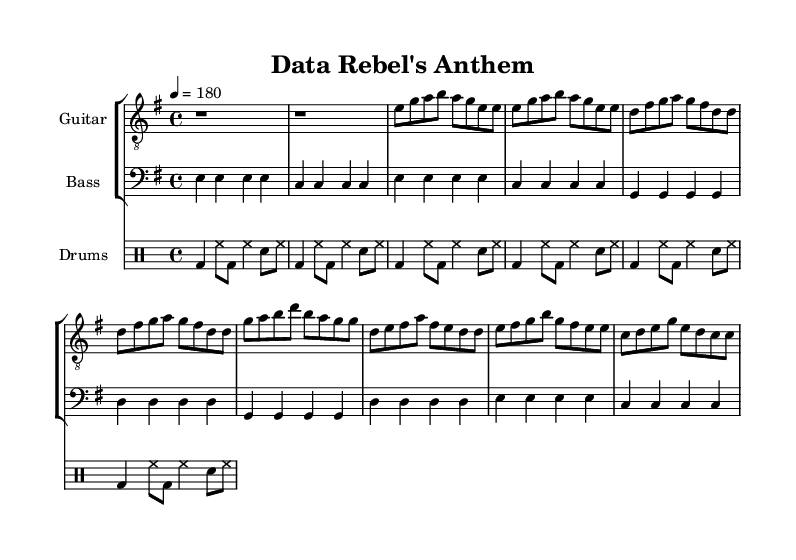What is the key signature of this music? The key signature is indicated at the beginning of the score. It shows one sharp, which corresponds to the E minor key signature.
Answer: E minor What is the time signature of this music? The time signature, located right after the key signature, is represented by 4/4. This indicates that there are four beats per measure and that the quarter note gets one beat.
Answer: 4/4 What is the tempo marking for this piece? The tempo marking, located at the beginning of the score, indicates that the piece is to be played at a speed of 180 beats per minute.
Answer: 180 How many measures are in the verse section of the song? The verse section consists of two repeated musical phrases, each containing four measures, totaling eight measures in the verse.
Answer: Eight measures In the chorus, what is the highest note played in the guitar part? By examining the chorus section of the guitar music, the highest note is B, which occurs in both of the two lines of the chorus.
Answer: B What musical style does this piece primarily reflect? The elements of fast tempo, straightforward chords, and rebellious lyrics are indicative of the punk rock genre, making it reflect punk music style.
Answer: Punk rock How many times is the word "data" mentioned in the lyrics? In the lyric section, the word "data" appears four times throughout the entire song, signifying its importance to the anthem's message.
Answer: Four times 